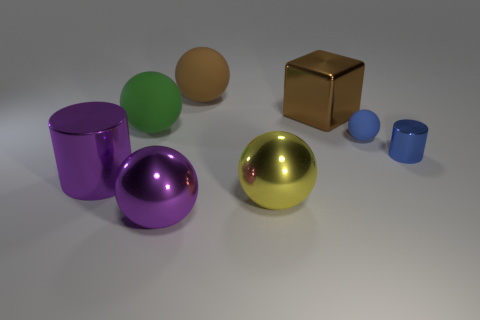The tiny cylinder that is the same material as the block is what color?
Your answer should be compact. Blue. Do the large brown thing that is on the left side of the large block and the large green thing have the same shape?
Provide a short and direct response. Yes. What number of things are matte spheres that are to the left of the large cube or objects that are behind the tiny cylinder?
Provide a short and direct response. 4. The other small rubber object that is the same shape as the green matte thing is what color?
Offer a very short reply. Blue. Is there anything else that is the same shape as the brown metallic object?
Ensure brevity in your answer.  No. There is a big yellow thing; is it the same shape as the big matte object that is to the right of the purple ball?
Ensure brevity in your answer.  Yes. What is the purple sphere made of?
Offer a very short reply. Metal. The blue thing that is the same shape as the brown rubber thing is what size?
Your response must be concise. Small. What number of other objects are the same material as the purple ball?
Offer a terse response. 4. Are the large purple ball and the sphere that is on the left side of the purple metallic sphere made of the same material?
Offer a very short reply. No. 